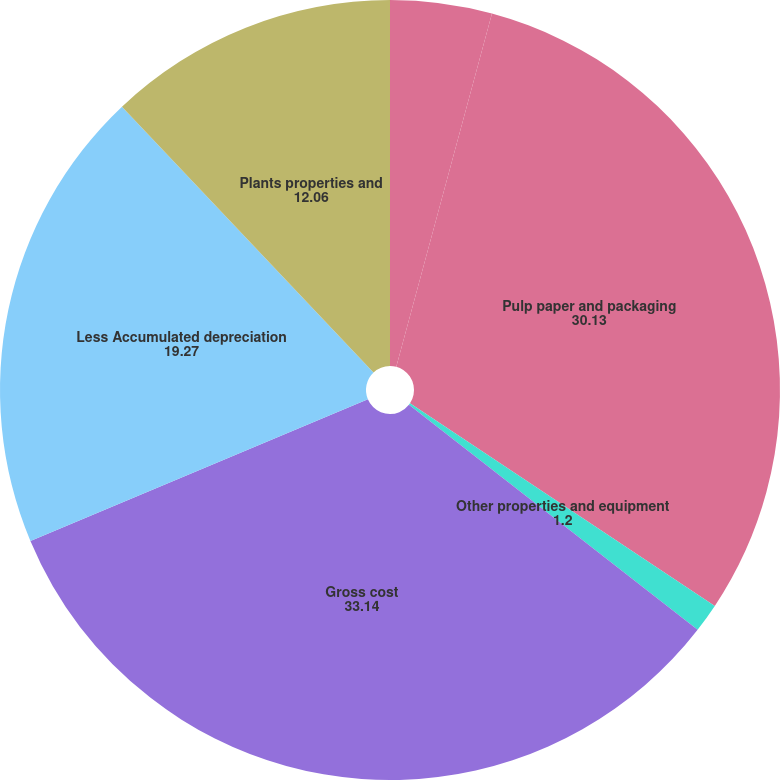<chart> <loc_0><loc_0><loc_500><loc_500><pie_chart><fcel>In millions at December 31<fcel>Pulp paper and packaging<fcel>Other properties and equipment<fcel>Gross cost<fcel>Less Accumulated depreciation<fcel>Plants properties and<nl><fcel>4.21%<fcel>30.13%<fcel>1.2%<fcel>33.14%<fcel>19.27%<fcel>12.06%<nl></chart> 